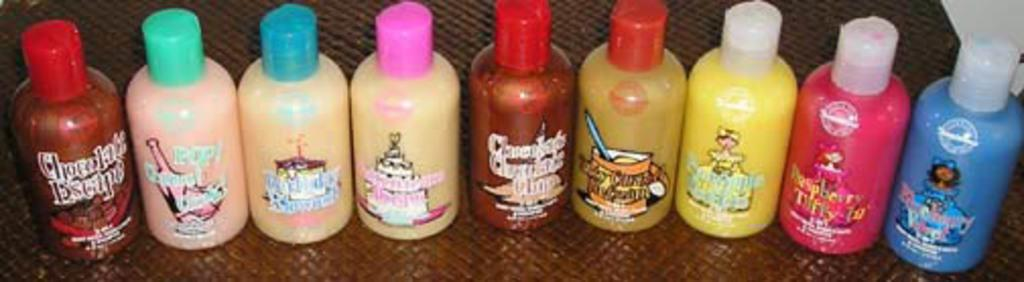What objects are present in the image? There are bottles in the image. Can you describe the appearance of the bottles? The bottles have different colors. What specific colors can be seen on the bottles? The colors mentioned are pink, blue, yellow, and red. What type of pencil can be seen in the image? There is no pencil present in the image; it only features bottles with different colors. 